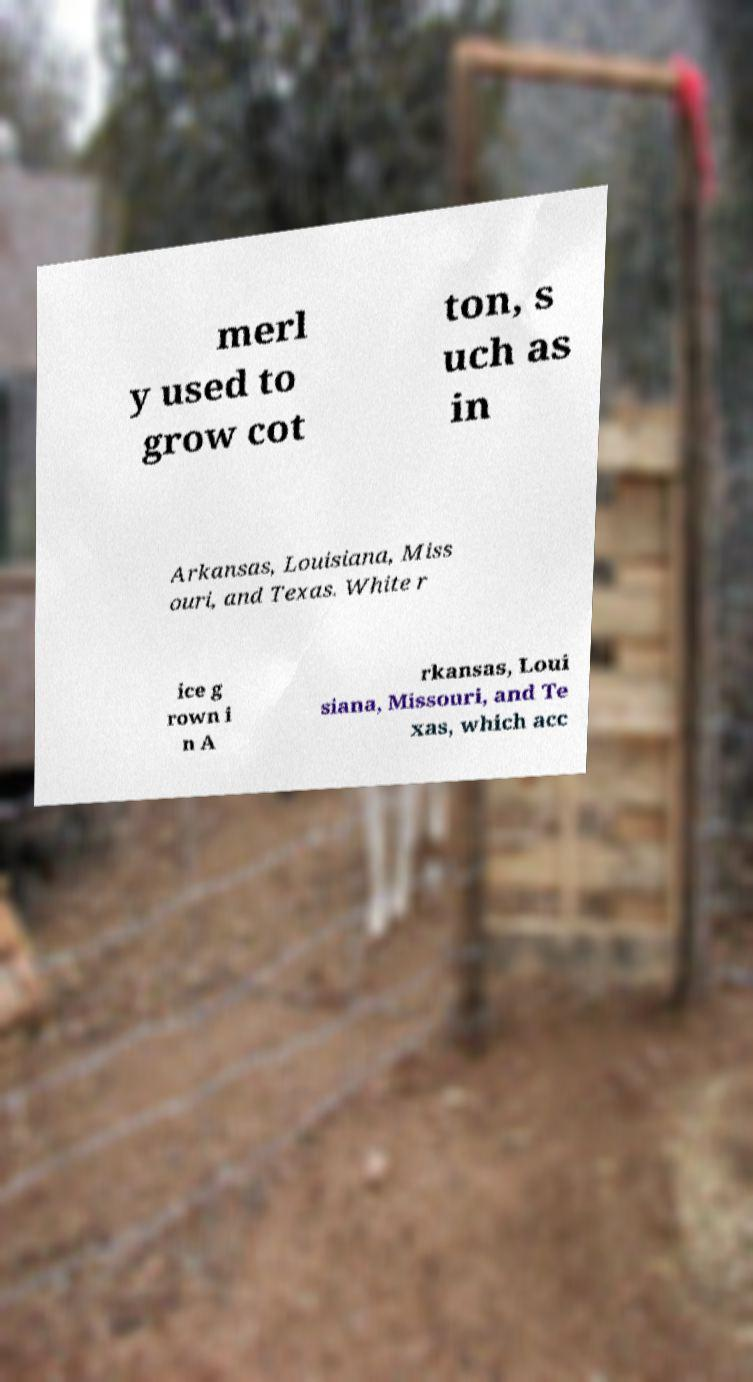I need the written content from this picture converted into text. Can you do that? merl y used to grow cot ton, s uch as in Arkansas, Louisiana, Miss ouri, and Texas. White r ice g rown i n A rkansas, Loui siana, Missouri, and Te xas, which acc 